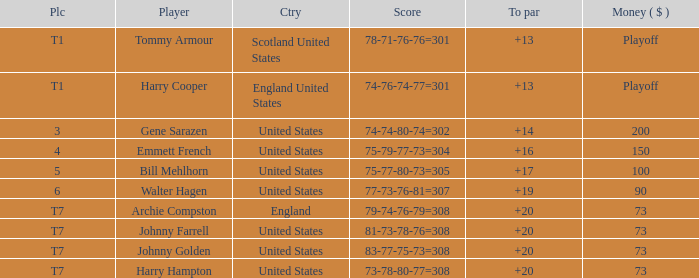What is the score for the United States when Harry Hampton is the player and the money is $73? 73-78-80-77=308. 